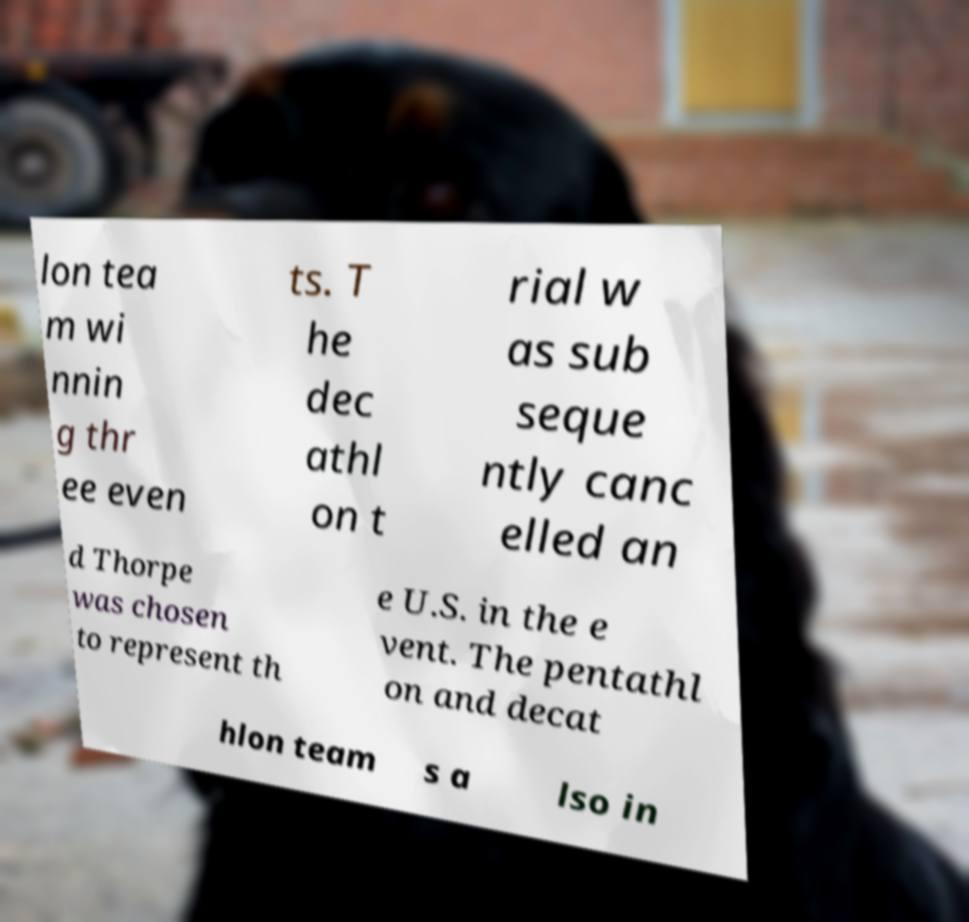Could you extract and type out the text from this image? lon tea m wi nnin g thr ee even ts. T he dec athl on t rial w as sub seque ntly canc elled an d Thorpe was chosen to represent th e U.S. in the e vent. The pentathl on and decat hlon team s a lso in 